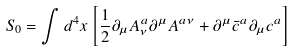Convert formula to latex. <formula><loc_0><loc_0><loc_500><loc_500>S _ { 0 } = \int d ^ { 4 } x \left [ \frac { 1 } { 2 } \partial _ { \mu } A ^ { a } _ { \nu } \partial ^ { \mu } A ^ { a \nu } + \partial ^ { \mu } \bar { c } ^ { a } \partial _ { \mu } c ^ { a } \right ]</formula> 